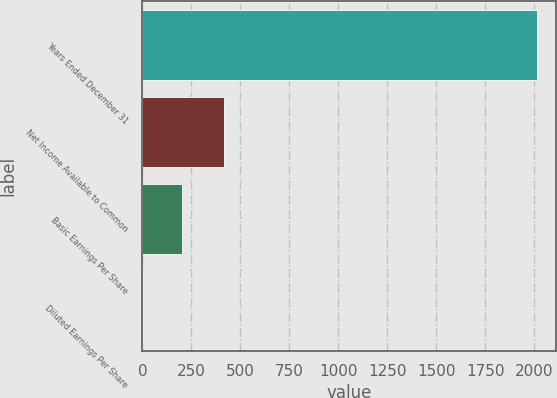Convert chart. <chart><loc_0><loc_0><loc_500><loc_500><bar_chart><fcel>Years Ended December 31<fcel>Net Income Available to Common<fcel>Basic Earnings Per Share<fcel>Diluted Earnings Per Share<nl><fcel>2011<fcel>415<fcel>202.52<fcel>1.58<nl></chart> 